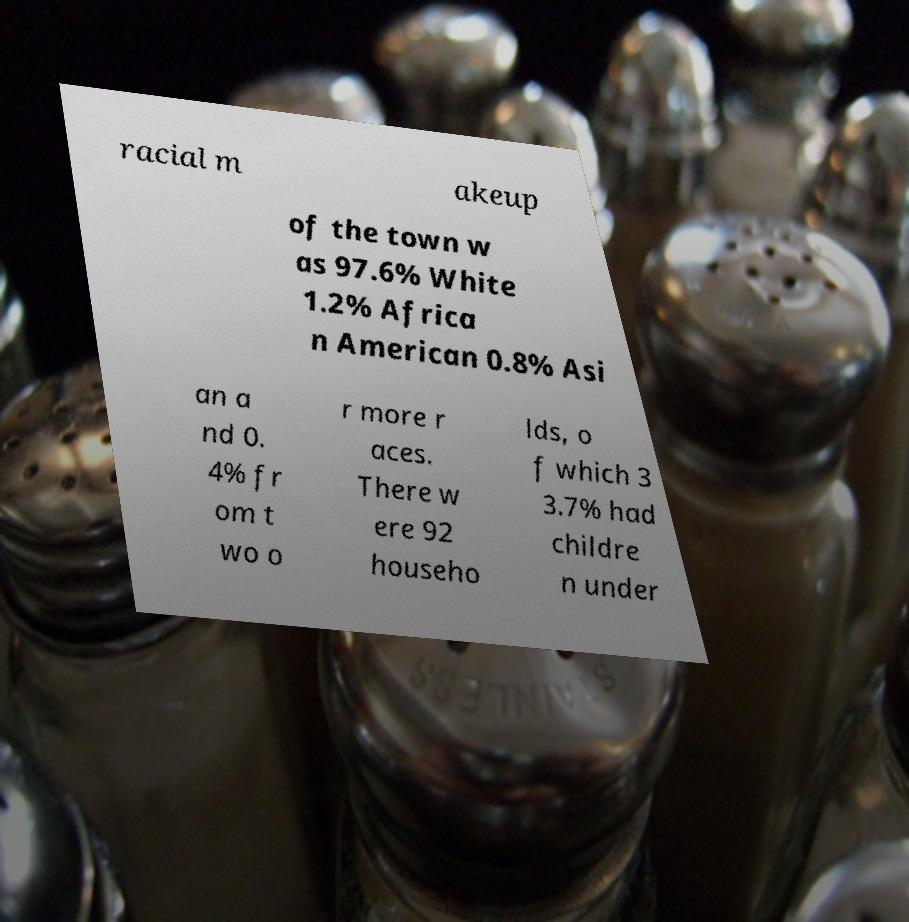Can you read and provide the text displayed in the image?This photo seems to have some interesting text. Can you extract and type it out for me? racial m akeup of the town w as 97.6% White 1.2% Africa n American 0.8% Asi an a nd 0. 4% fr om t wo o r more r aces. There w ere 92 househo lds, o f which 3 3.7% had childre n under 